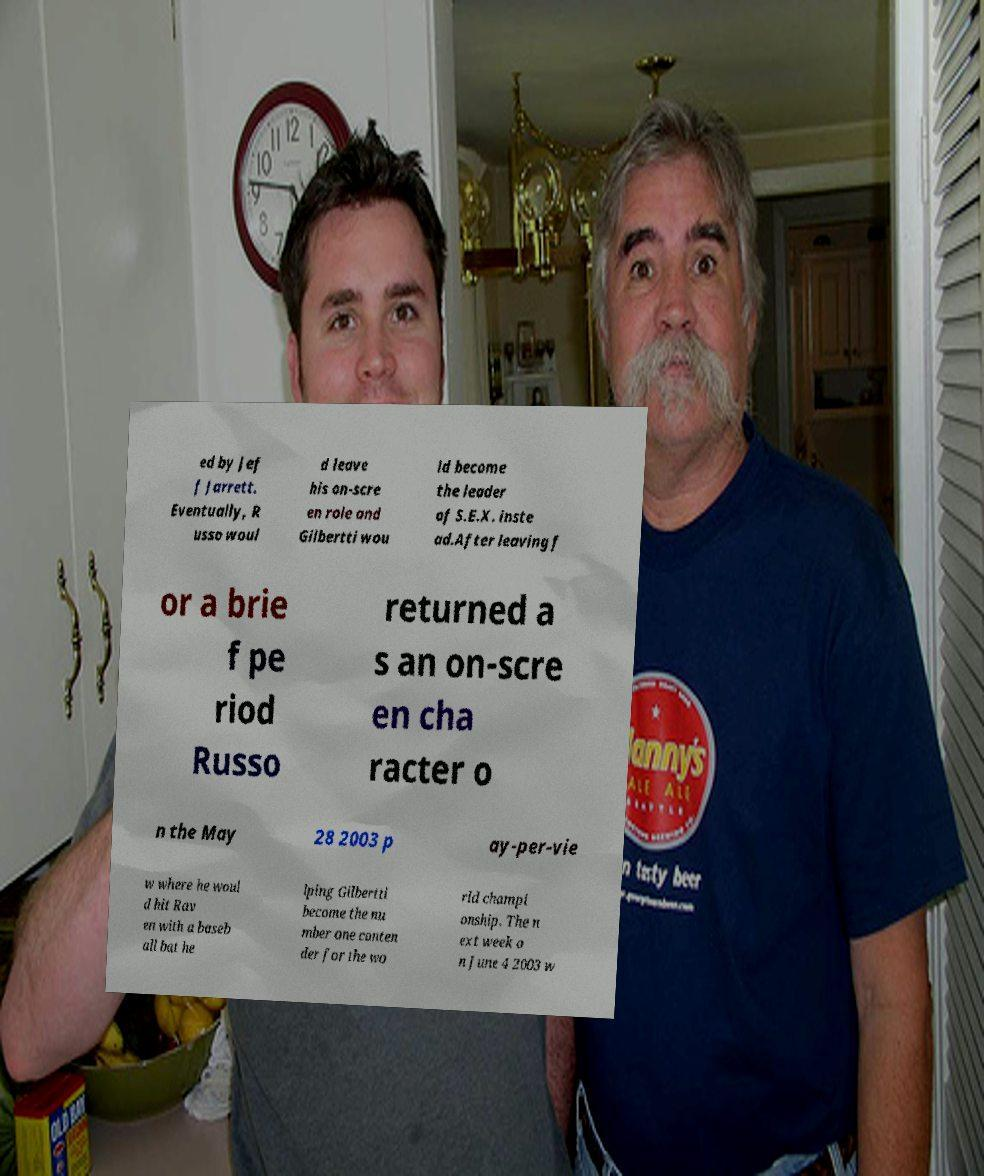Please read and relay the text visible in this image. What does it say? ed by Jef f Jarrett. Eventually, R usso woul d leave his on-scre en role and Gilbertti wou ld become the leader of S.E.X. inste ad.After leaving f or a brie f pe riod Russo returned a s an on-scre en cha racter o n the May 28 2003 p ay-per-vie w where he woul d hit Rav en with a baseb all bat he lping Gilbertti become the nu mber one conten der for the wo rld champi onship. The n ext week o n June 4 2003 w 